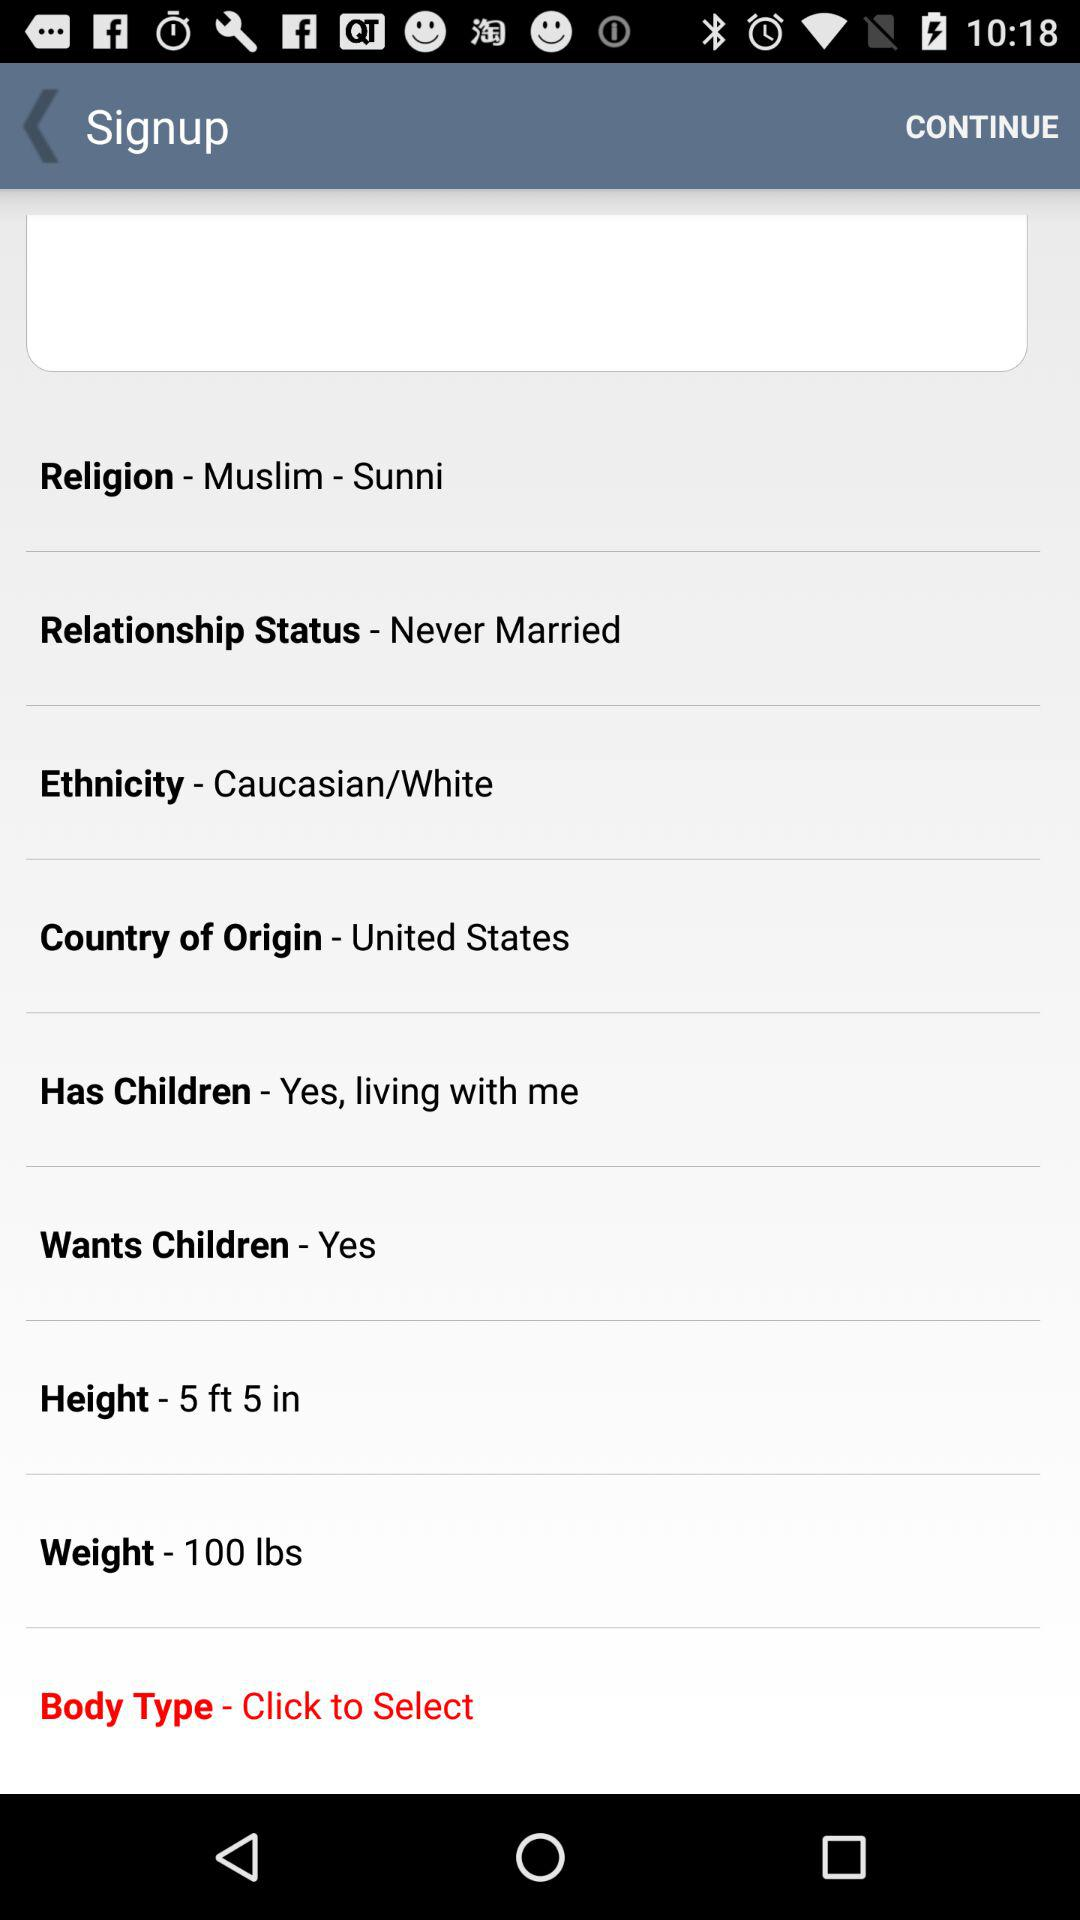What is the relationship status? The relationship status is "Never Married". 